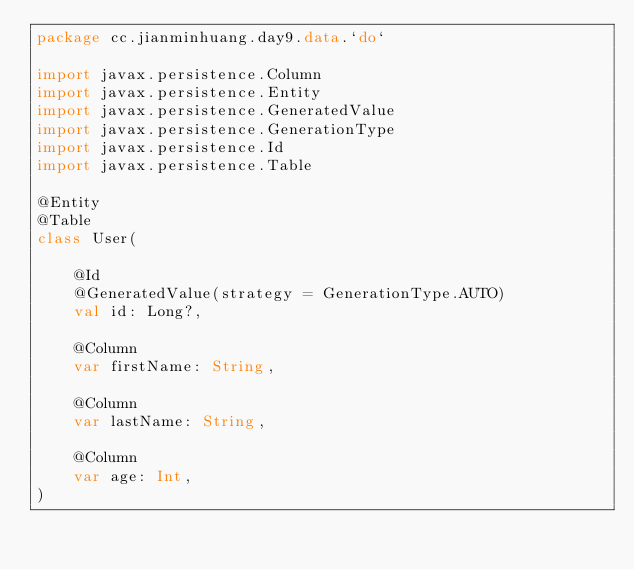<code> <loc_0><loc_0><loc_500><loc_500><_Kotlin_>package cc.jianminhuang.day9.data.`do`

import javax.persistence.Column
import javax.persistence.Entity
import javax.persistence.GeneratedValue
import javax.persistence.GenerationType
import javax.persistence.Id
import javax.persistence.Table

@Entity
@Table
class User(

    @Id
    @GeneratedValue(strategy = GenerationType.AUTO)
    val id: Long?,

    @Column
    var firstName: String,

    @Column
    var lastName: String,

    @Column
    var age: Int,
)</code> 